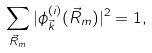<formula> <loc_0><loc_0><loc_500><loc_500>\sum _ { \vec { R } _ { m } } | \phi ^ { ( i ) } _ { \vec { k } } ( \vec { R } _ { m } ) | ^ { 2 } = 1 ,</formula> 